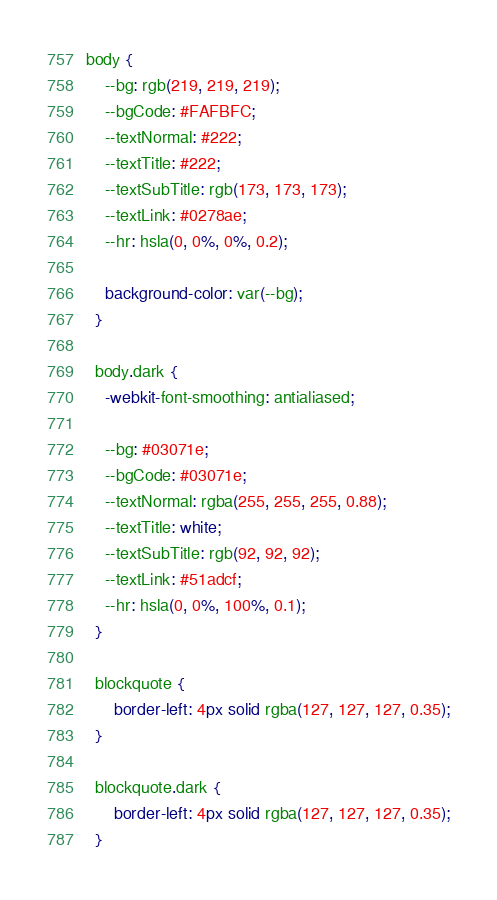<code> <loc_0><loc_0><loc_500><loc_500><_CSS_>body {
    --bg: rgb(219, 219, 219);
    --bgCode: #FAFBFC;
    --textNormal: #222;
    --textTitle: #222;
    --textSubTitle: rgb(173, 173, 173);
    --textLink: #0278ae;
    --hr: hsla(0, 0%, 0%, 0.2);
  
    background-color: var(--bg);
  }
  
  body.dark {
    -webkit-font-smoothing: antialiased;
  
    --bg: #03071e;
    --bgCode: #03071e;
    --textNormal: rgba(255, 255, 255, 0.88);
    --textTitle: white;
    --textSubTitle: rgb(92, 92, 92);
    --textLink: #51adcf;
    --hr: hsla(0, 0%, 100%, 0.1);
  }

  blockquote {
      border-left: 4px solid rgba(127, 127, 127, 0.35);
  }

  blockquote.dark {
      border-left: 4px solid rgba(127, 127, 127, 0.35);
  }</code> 